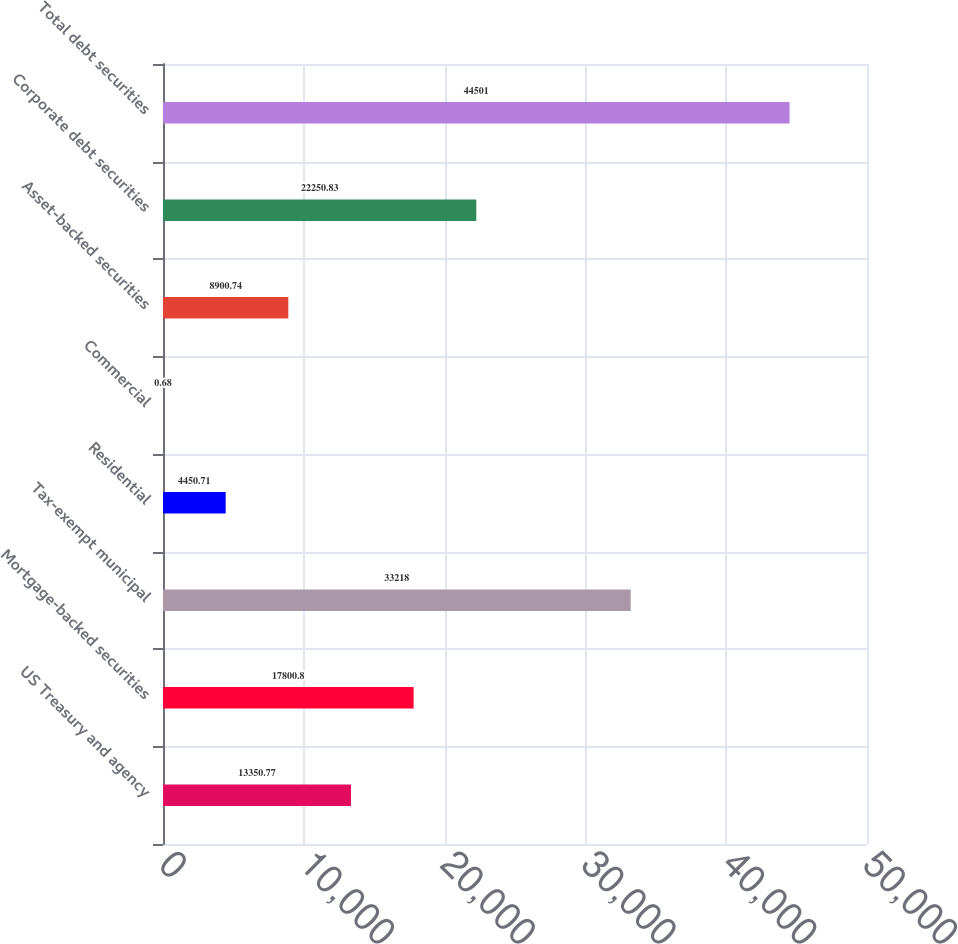<chart> <loc_0><loc_0><loc_500><loc_500><bar_chart><fcel>US Treasury and agency<fcel>Mortgage-backed securities<fcel>Tax-exempt municipal<fcel>Residential<fcel>Commercial<fcel>Asset-backed securities<fcel>Corporate debt securities<fcel>Total debt securities<nl><fcel>13350.8<fcel>17800.8<fcel>33218<fcel>4450.71<fcel>0.68<fcel>8900.74<fcel>22250.8<fcel>44501<nl></chart> 